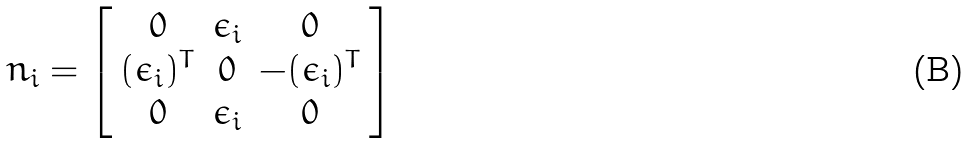<formula> <loc_0><loc_0><loc_500><loc_500>\ n _ { i } = \left [ \begin{array} { c c c } 0 & \epsilon _ { i } & 0 \\ ( \epsilon _ { i } ) ^ { T } & 0 & - ( \epsilon _ { i } ) ^ { T } \\ 0 & \epsilon _ { i } & 0 \end{array} \right ]</formula> 